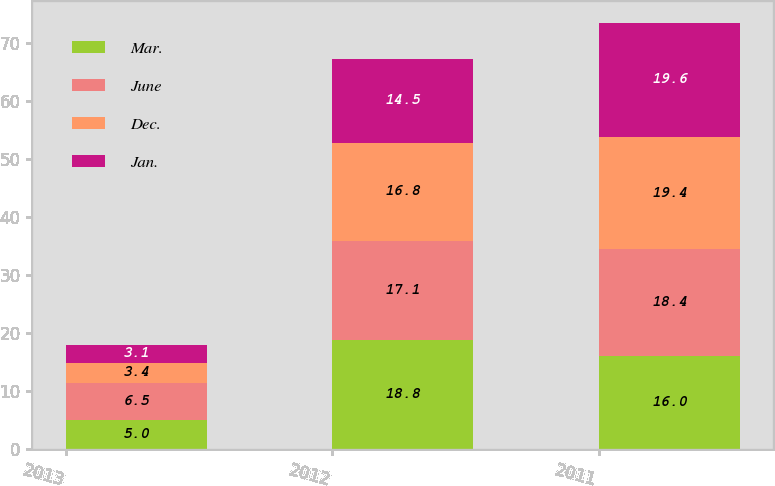<chart> <loc_0><loc_0><loc_500><loc_500><stacked_bar_chart><ecel><fcel>2013<fcel>2012<fcel>2011<nl><fcel>Mar.<fcel>5<fcel>18.8<fcel>16<nl><fcel>June<fcel>6.5<fcel>17.1<fcel>18.4<nl><fcel>Dec.<fcel>3.4<fcel>16.8<fcel>19.4<nl><fcel>Jan.<fcel>3.1<fcel>14.5<fcel>19.6<nl></chart> 